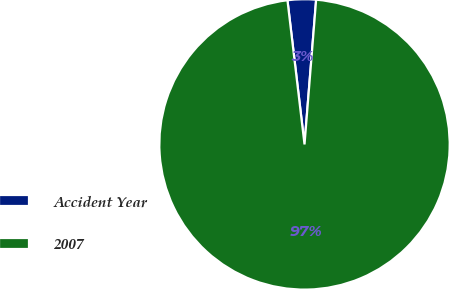Convert chart to OTSL. <chart><loc_0><loc_0><loc_500><loc_500><pie_chart><fcel>Accident Year<fcel>2007<nl><fcel>3.15%<fcel>96.85%<nl></chart> 